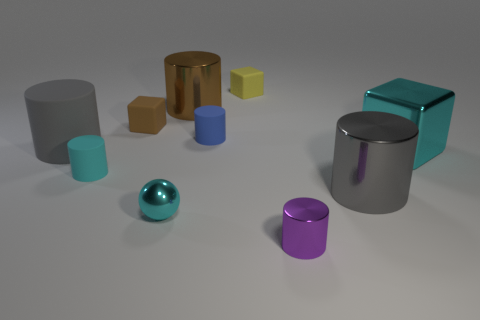The tiny cylinder that is both behind the tiny metallic cylinder and on the right side of the tiny brown block is what color?
Make the answer very short. Blue. Is the number of tiny gray matte cubes less than the number of large gray metallic objects?
Give a very brief answer. Yes. There is a large matte cylinder; does it have the same color as the metal object that is behind the metal cube?
Your answer should be very brief. No. Is the number of cyan metallic blocks that are in front of the big cyan shiny cube the same as the number of brown things that are on the left side of the brown cube?
Ensure brevity in your answer.  Yes. How many other rubber objects are the same shape as the blue thing?
Give a very brief answer. 2. Are there any big yellow matte things?
Offer a very short reply. No. Does the small brown cube have the same material as the yellow block on the left side of the small purple metal thing?
Your answer should be very brief. Yes. There is a cyan sphere that is the same size as the purple object; what is its material?
Your response must be concise. Metal. Are there any balls that have the same material as the small brown object?
Provide a succinct answer. No. There is a tiny rubber cylinder to the right of the shiny sphere in front of the cyan rubber object; is there a large gray cylinder left of it?
Offer a terse response. Yes. 